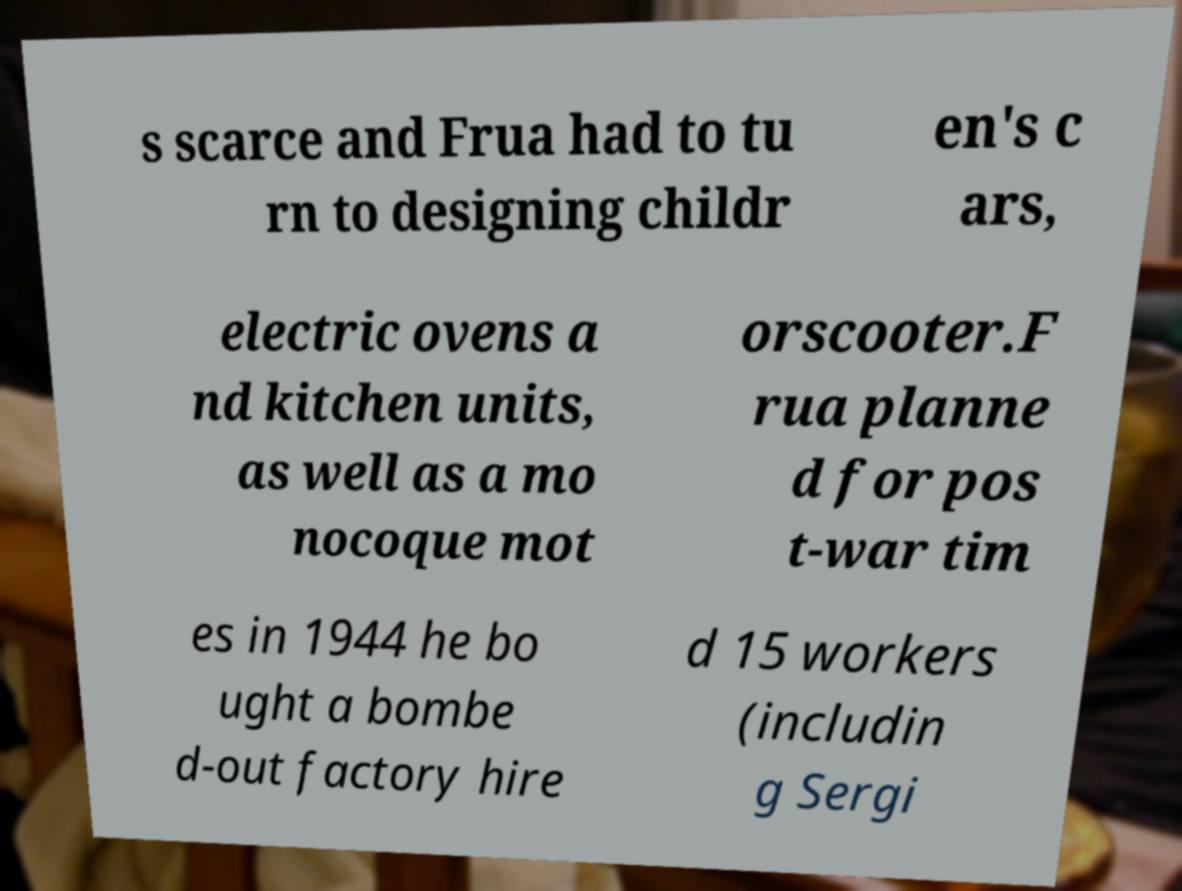What messages or text are displayed in this image? I need them in a readable, typed format. s scarce and Frua had to tu rn to designing childr en's c ars, electric ovens a nd kitchen units, as well as a mo nocoque mot orscooter.F rua planne d for pos t-war tim es in 1944 he bo ught a bombe d-out factory hire d 15 workers (includin g Sergi 